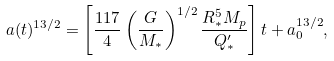Convert formula to latex. <formula><loc_0><loc_0><loc_500><loc_500>a ( t ) ^ { 1 3 / 2 } = \left [ \frac { 1 1 7 } { 4 } \left ( \frac { G } { M _ { * } } \right ) ^ { 1 / 2 } \frac { R _ { * } ^ { 5 } M _ { p } } { Q ^ { \prime } _ { * } } \right ] t + a _ { 0 } ^ { 1 3 / 2 } ,</formula> 